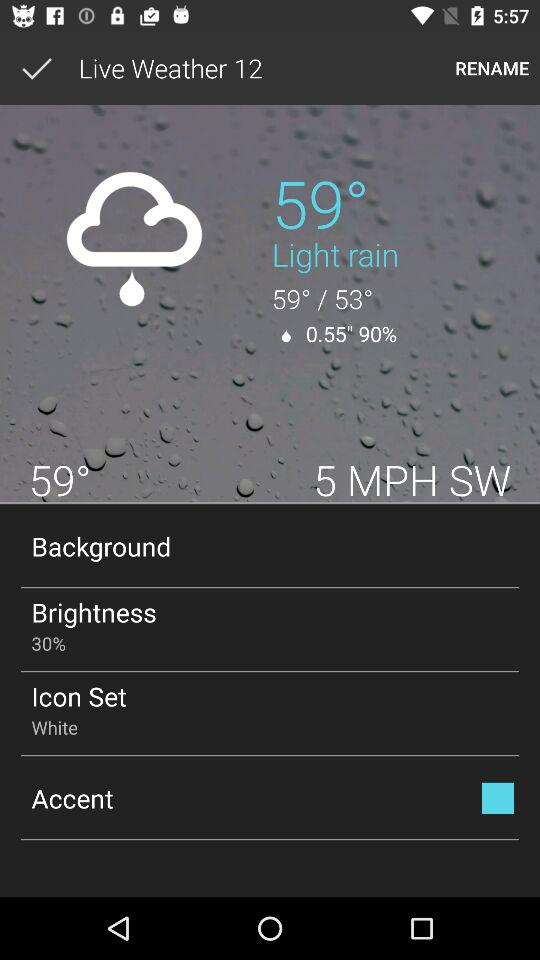What is the wind speed? The wind speed is 5 mph. 